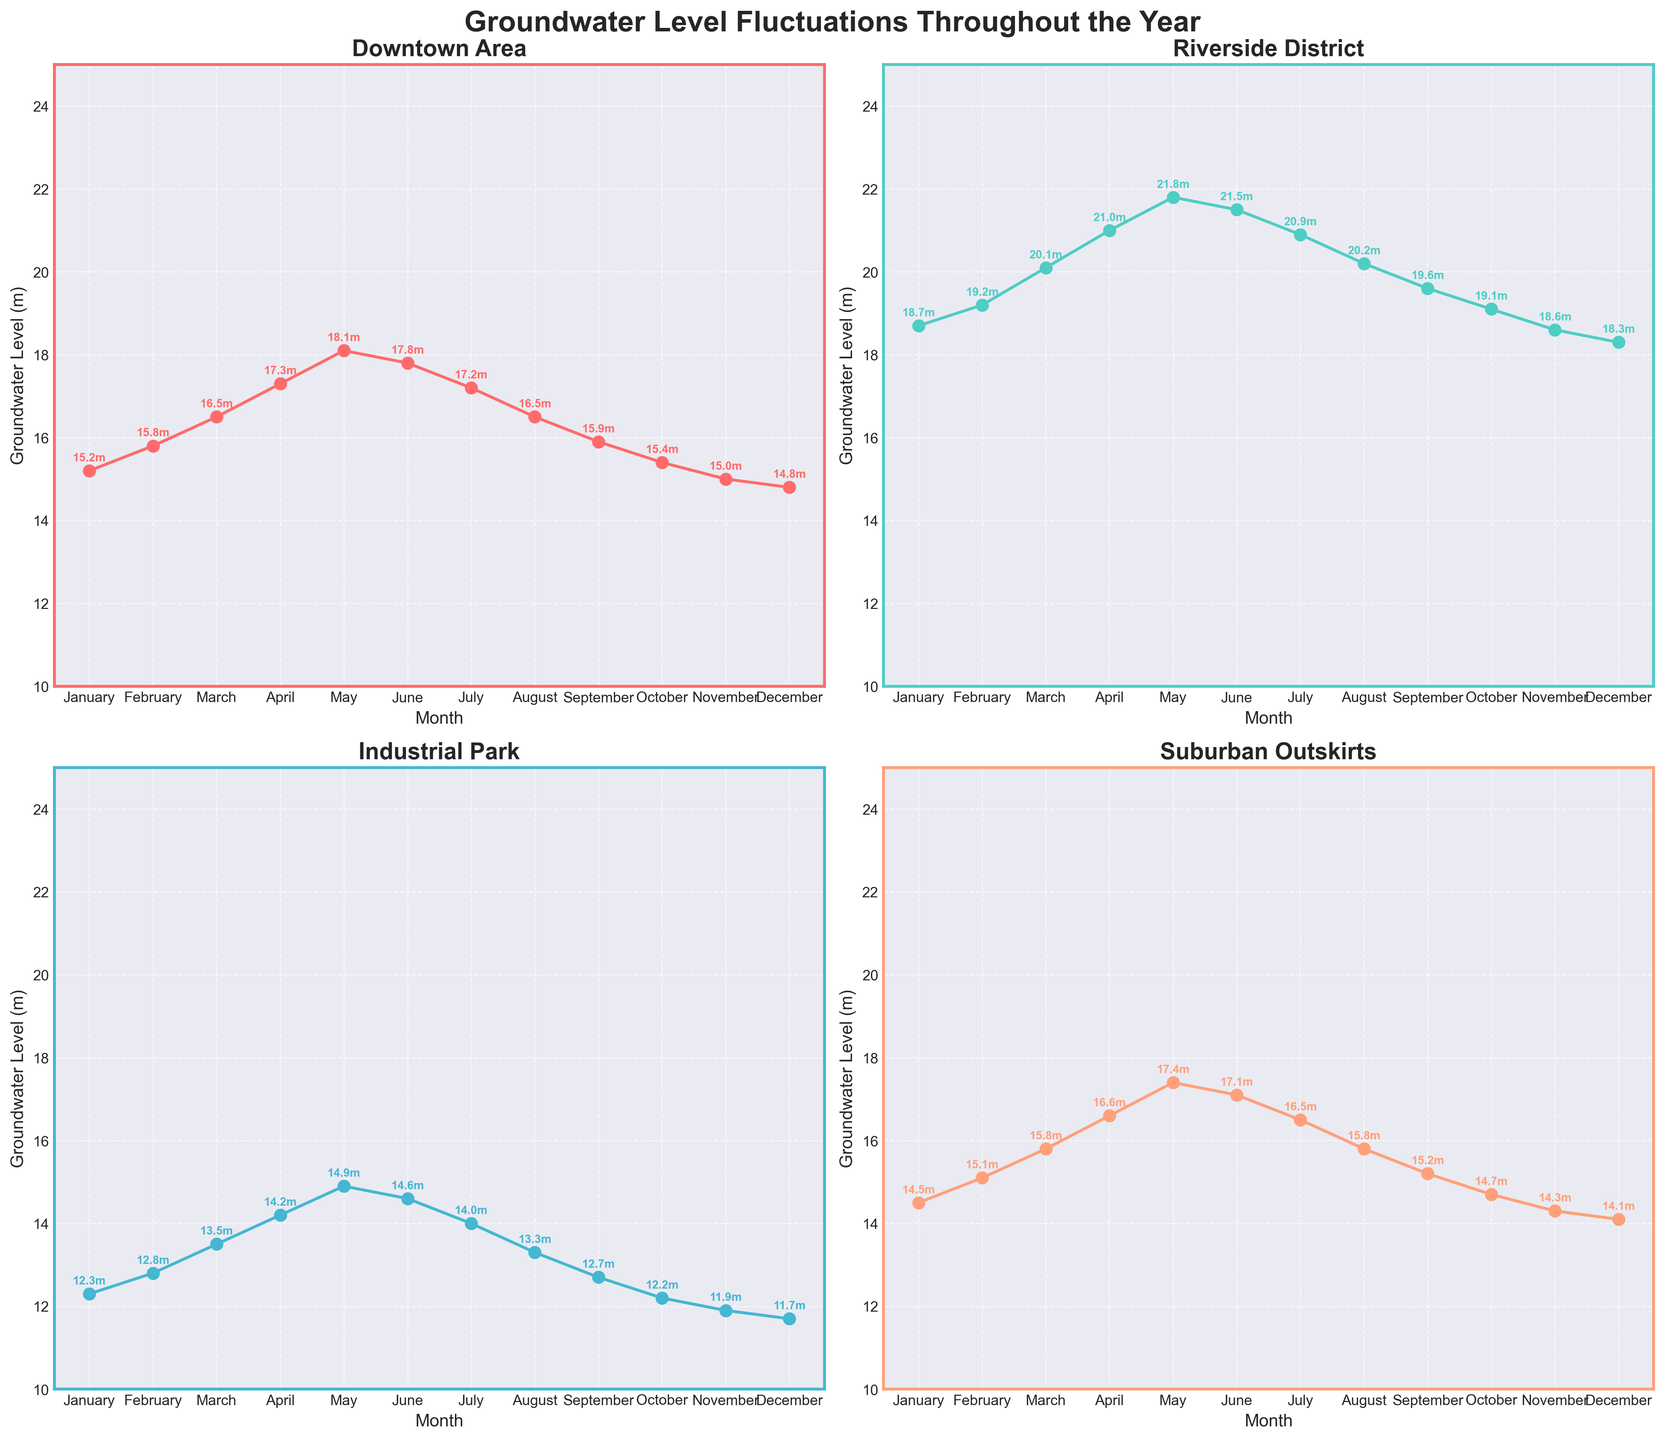What is the title of each subplot? The subplot's title is located at the top of each individual plot. For the first subplot, it's "Downtown Area"; for the second, "Riverside District"; for the third, "Industrial Park"; and for the fourth, "Suburban Outskirts."
Answer: Downtown Area, Riverside District, Industrial Park, Suburban Outskirts In which month does the Riverside District have the highest groundwater level? By observing the plot for the Riverside District, the peak value appears in May, with a level of 21.8 meters.
Answer: May What is the lowest groundwater level recorded in the Suburban Outskirts? By checking the Suburban Outskirts plot, the lowest value is in December, with a groundwater level of 14.1 meters.
Answer: 14.1 meters Compare the maximum groundwater levels throughout the year for the Downtown Area and the Industrial Park. Which has the higher value, and what is the difference? The maximum value for the Downtown Area is 18.1 meters in May, and for the Industrial Park, it is 14.9 meters in May. The Downtown Area has the higher value. The difference is calculated as 18.1 - 14.9 = 3.2 meters.
Answer: Downtown Area, 3.2 meters In which month does the Downtown Area experience a groundwater level below 15 meters? Observing the Downtown Area plot, January, October, November, and December have groundwater levels below 15 meters.
Answer: January, October, November, December What is the overall trend of groundwater levels in the Riverside District from January to December? The trend in the Riverside District plot shows an increase in groundwater levels from January to May, a slight decrease until July, and then a gradual decline from August to December.
Answer: Increasing until May, then gradually decreasing What is the difference in groundwater levels between February and November in the Industrial Park? By checking the Industrial Park plot, February has a level of 12.8 meters, and November has a level of 11.9 meters. The difference is 12.8 - 11.9 = 0.9 meters.
Answer: 0.9 meters Which location has the most stable groundwater levels throughout the year, and what criteria are you using to determine stability? Stability can be judged by the smallest variance in groundwater levels. The Industrial Park has values ranging from 11.7 to 14.9 meters, the smallest range (3.2 meters).
Answer: Industrial Park, 3.2 meters range In which month do all locations except the Suburban Outskirts have their lowest groundwater level? Observing the plots, December shows the lowest groundwater levels for Downtown Area (14.8m), Riverside District (18.3m), and Industrial Park (11.7m). The Suburban Outskirts has its lowest in November.
Answer: December Calculate the average groundwater level for March across all locations. Summing the values for March: Downtown Area (16.5), Riverside District (20.1), Industrial Park (13.5), and Suburban Outskirts (15.8), gives 16.5 + 20.1 + 13.5 + 15.8 = 65.9. The average is 65.9 / 4 = 16.475 meters.
Answer: 16.475 meters 